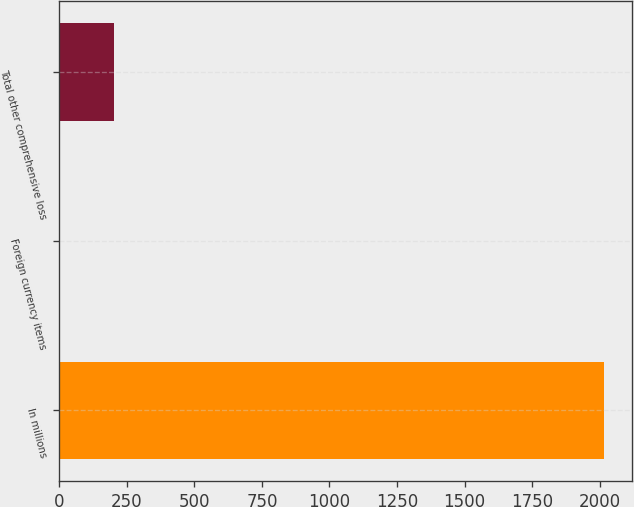Convert chart to OTSL. <chart><loc_0><loc_0><loc_500><loc_500><bar_chart><fcel>In millions<fcel>Foreign currency items<fcel>Total other comprehensive loss<nl><fcel>2017<fcel>0.6<fcel>202.24<nl></chart> 